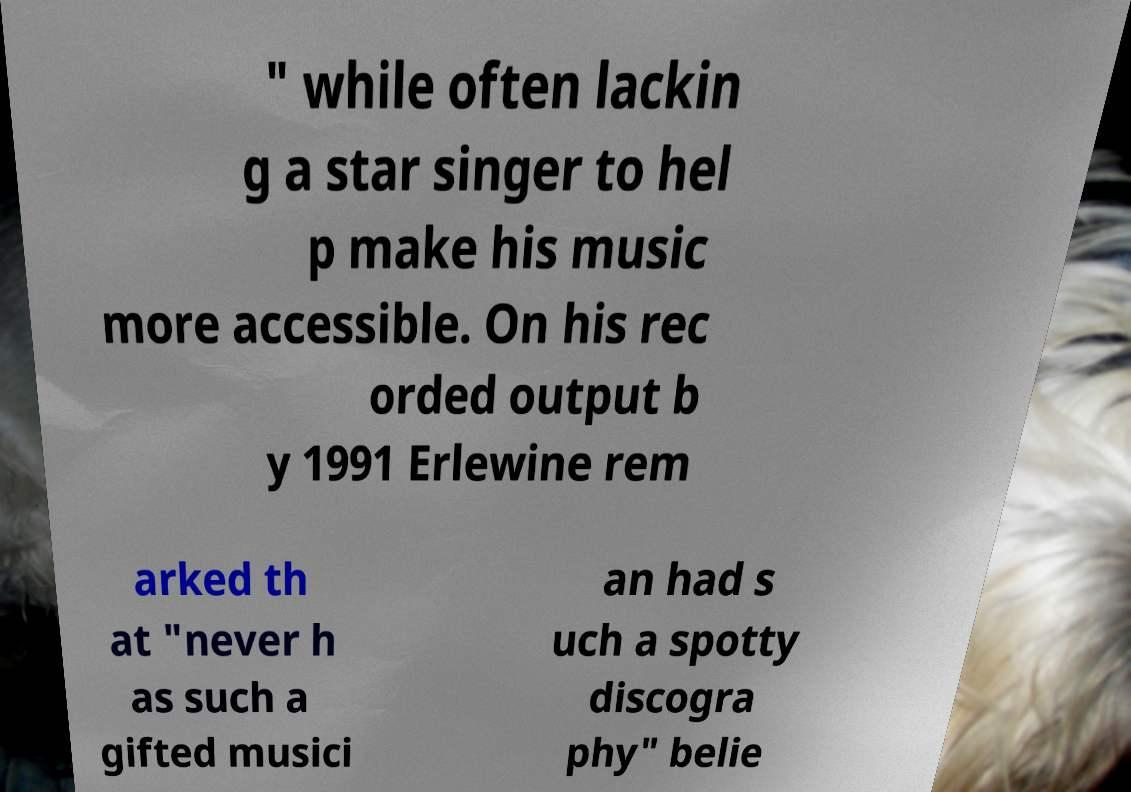Can you read and provide the text displayed in the image?This photo seems to have some interesting text. Can you extract and type it out for me? " while often lackin g a star singer to hel p make his music more accessible. On his rec orded output b y 1991 Erlewine rem arked th at "never h as such a gifted musici an had s uch a spotty discogra phy" belie 